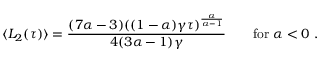<formula> <loc_0><loc_0><loc_500><loc_500>\langle L _ { 2 } ( \tau ) \rangle = \frac { ( 7 \alpha - 3 ) ( ( 1 - \alpha ) \gamma \tau ) ^ { \frac { \alpha } { \alpha - 1 } } } { 4 ( 3 \alpha - 1 ) \gamma } \quad f o r \ \alpha < 0 \ .</formula> 